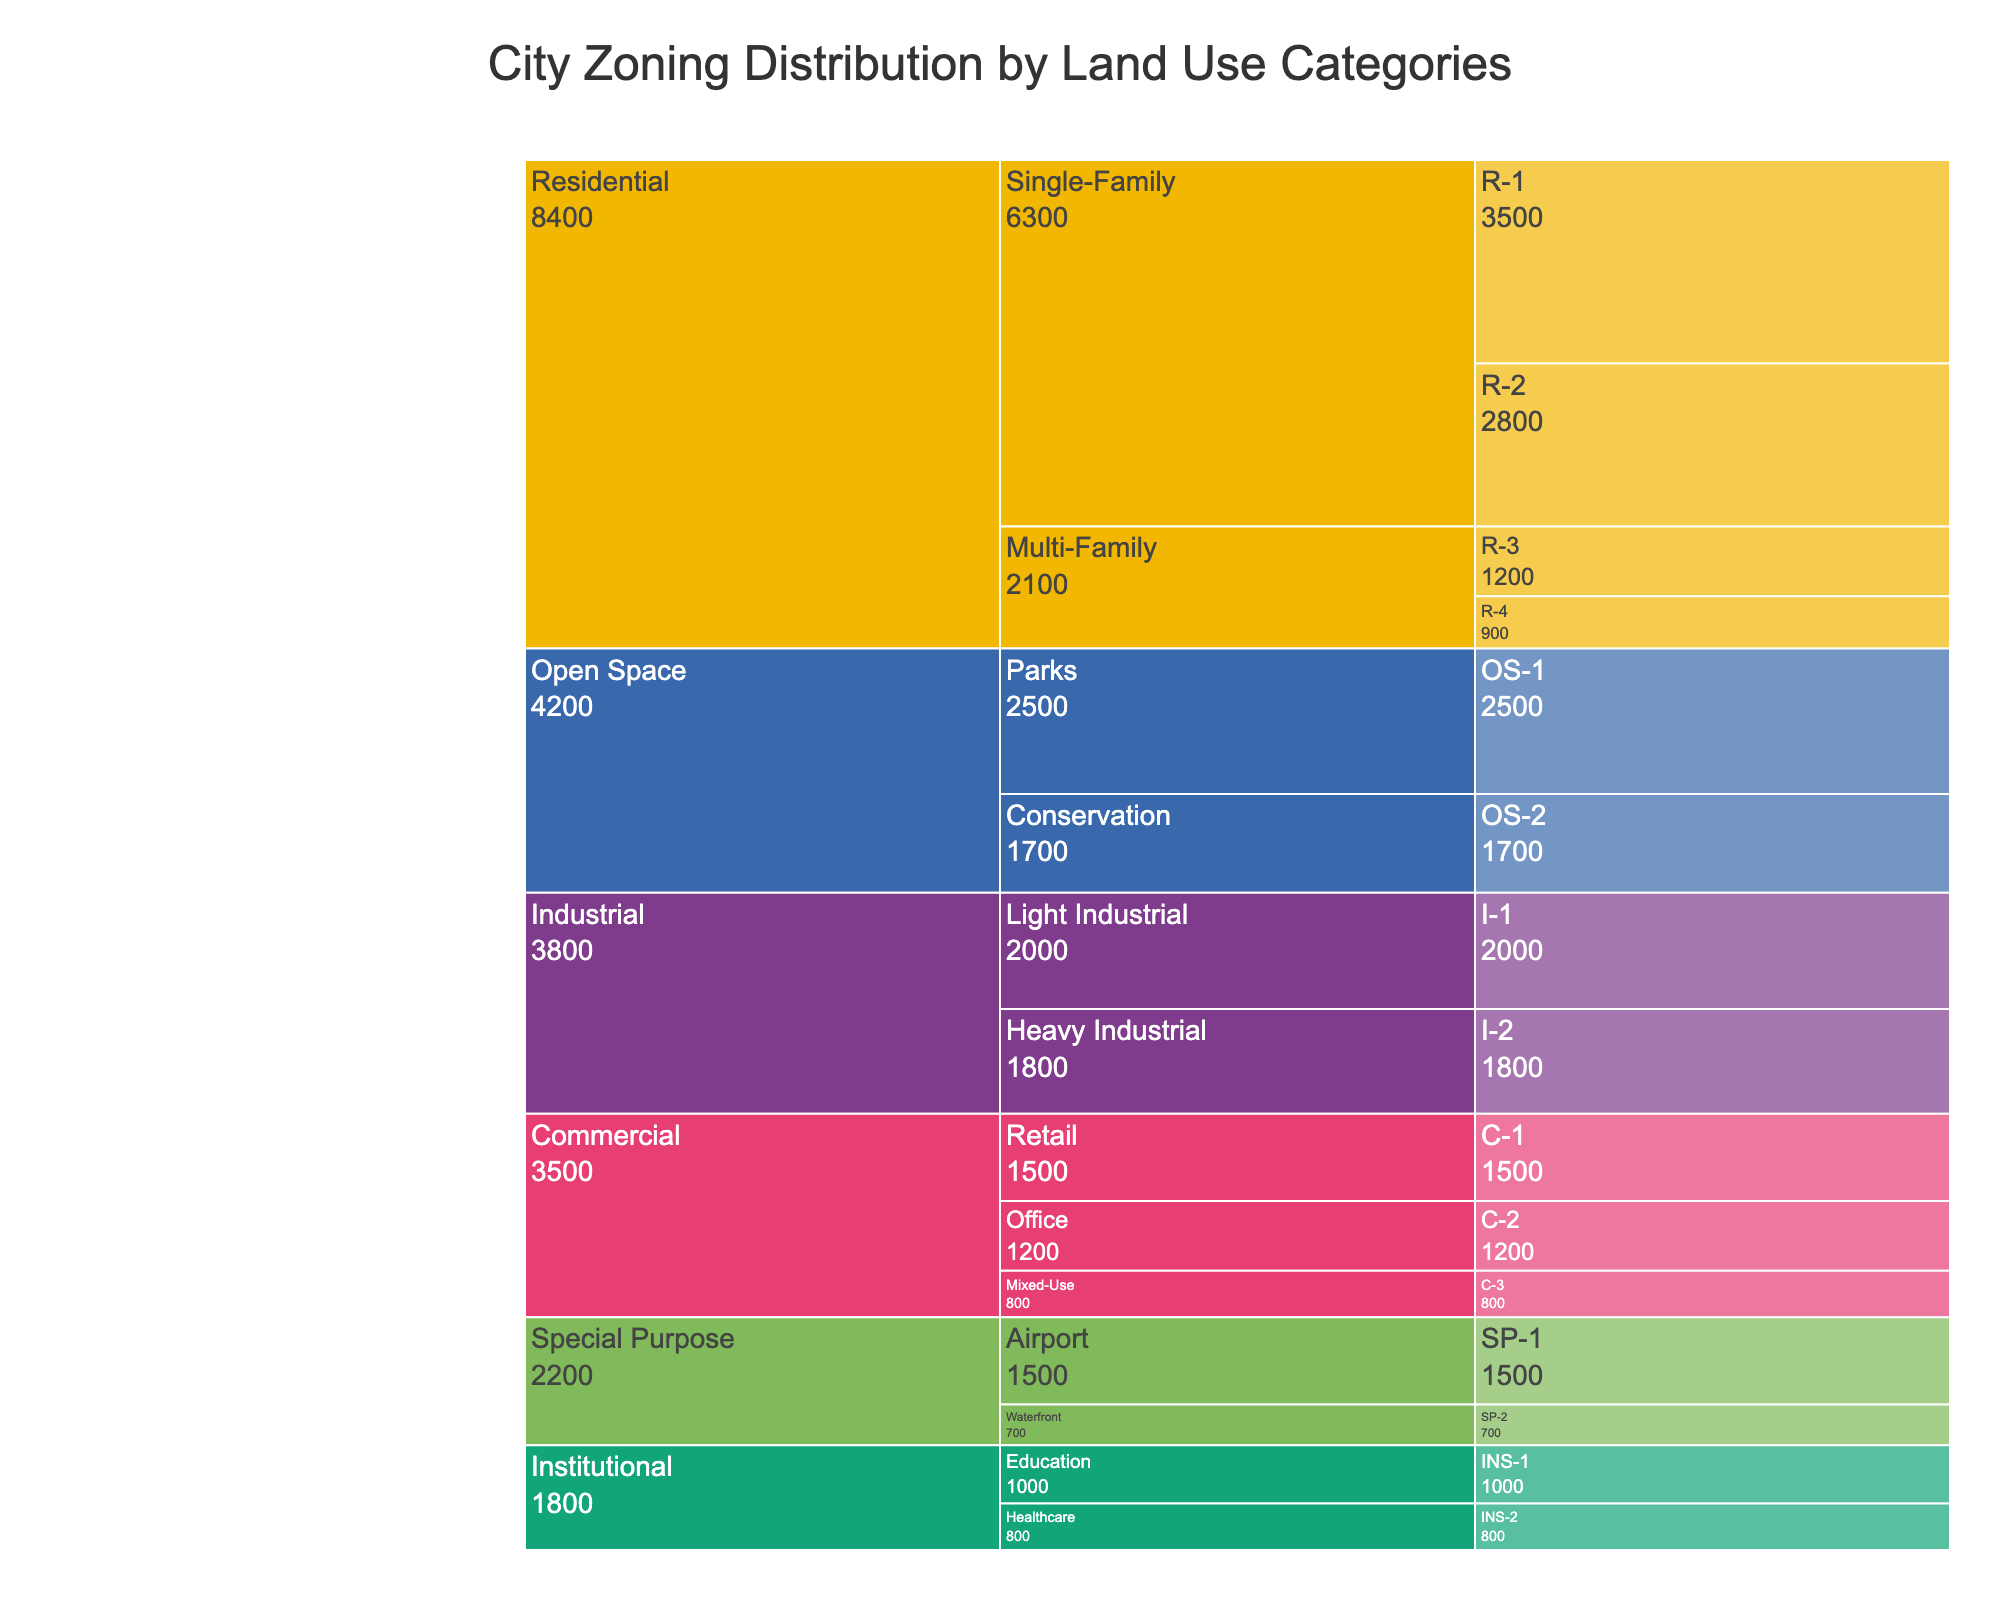How many main categories of land use are displayed in the figure? The title mentions "City Zoning Distribution by Land Use Categories". By looking at the top level of the icicle chart, we can see different colors representing different categories. Count these categories for the answer.
Answer: 5 What's the area of the largest subcategory under Residential land use? The Residential category can be broken down into Single-Family and Multi-Family subcategories. By looking at the values under these categories, compare their areas and identify the largest one.
Answer: 6300 How does the area of Industrial (I-1) compare to Industrial (I-2)? Locate the Industrial category and its subcategories I-1 and I-2 in the chart. Compare their areas by looking at the values.
Answer: I-1 is larger What is the total area designated for Open Space (OS-1 and OS-2)? Both OS-1 and OS-2 are subcategories under Open Space. To find the total area, add their values: 2500 + 1700.
Answer: 4200 Which category has the smallest total area? Look at all the main categories and their total areas, which are the sum of the areas under each category's subcategories. Identify the category with the smallest sum.
Answer: Special Purpose Which zone has the highest area within the Institutional category? Find the Institutional category and look at its subcategories (Education and Healthcare). Compare the areas assigned to each zone (INS-1 and INS-2).
Answer: INS-1 Are there more zones designated for Residential or Commercial use, and by how many? Count the number of subcategories in both the Residential and Commercial categories. Compare the counts to determine which has more zones and the difference.
Answer: Residential by 2 What is the combined area of all Special Purpose zones? Add the areas of all zones under the Special Purpose category: Airport (1500) and Waterfront (700).
Answer: 2200 Which subcategory has the smallest area under the Commercial category? Examine the areas under the Retail, Office, and Mixed-Use subcategories of the Commercial category. Identify the one with the smallest value.
Answer: Mixed-Use How does the area of Residential zones compare to that of Industrial zones? Add up the areas of all Residential zones and all Industrial zones. Compare the summed values to determine which is larger.
Answer: Residential is larger 